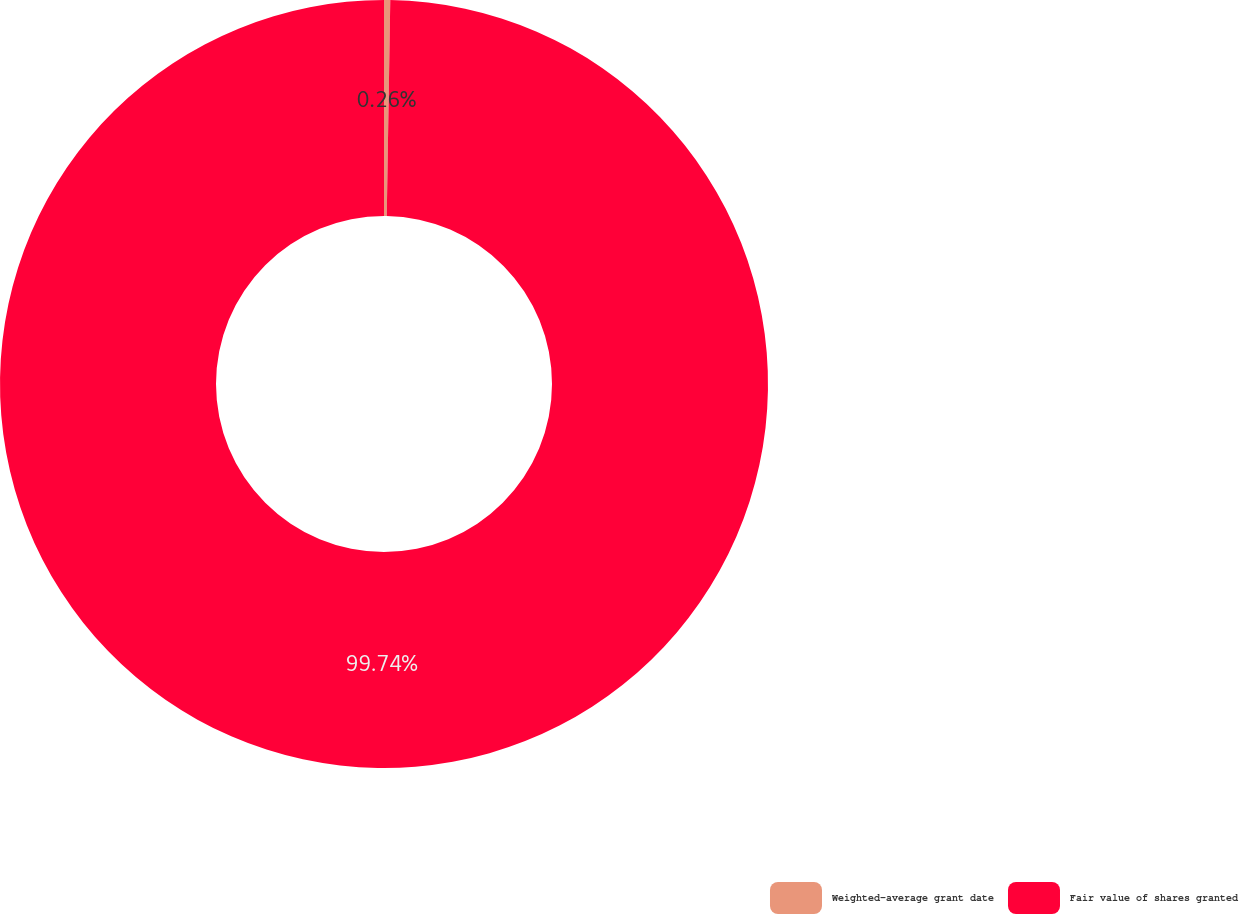Convert chart. <chart><loc_0><loc_0><loc_500><loc_500><pie_chart><fcel>Weighted-average grant date<fcel>Fair value of shares granted<nl><fcel>0.26%<fcel>99.74%<nl></chart> 